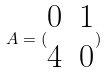<formula> <loc_0><loc_0><loc_500><loc_500>A = ( \begin{matrix} 0 & 1 \\ 4 & 0 \end{matrix} )</formula> 